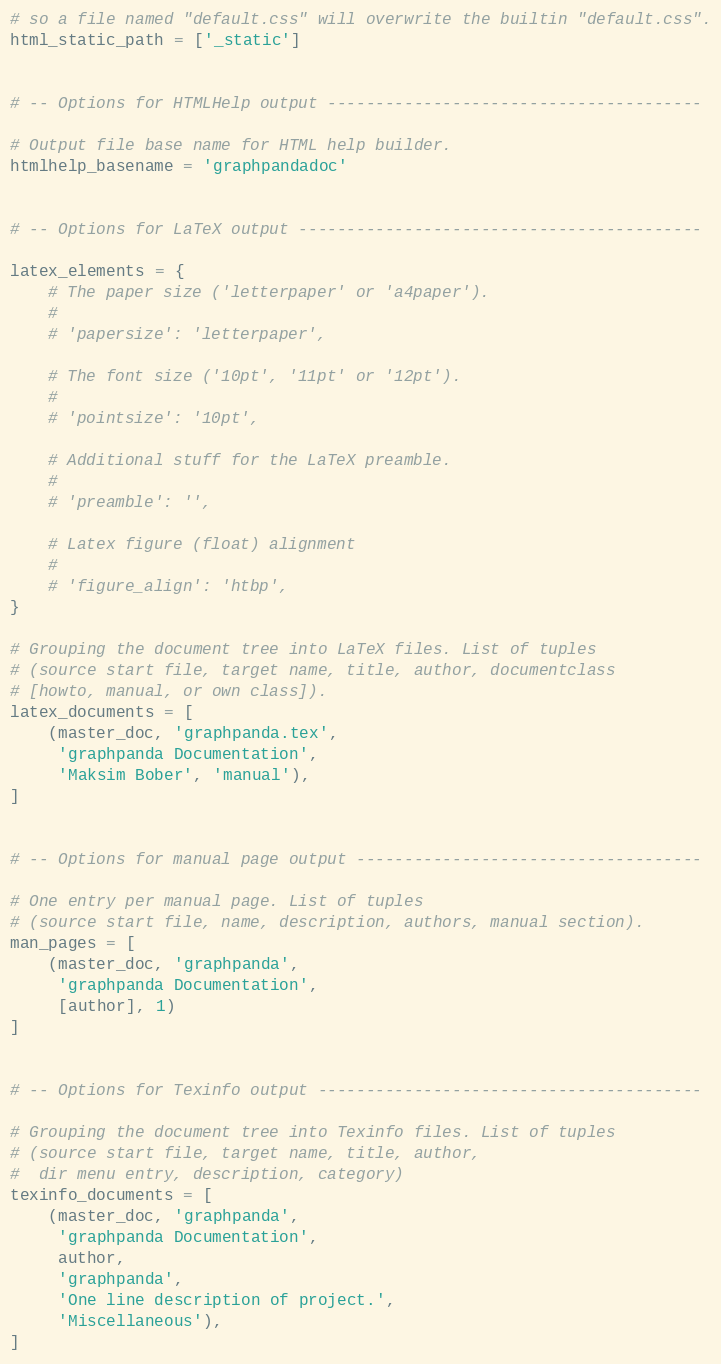<code> <loc_0><loc_0><loc_500><loc_500><_Python_># so a file named "default.css" will overwrite the builtin "default.css".
html_static_path = ['_static']


# -- Options for HTMLHelp output ---------------------------------------

# Output file base name for HTML help builder.
htmlhelp_basename = 'graphpandadoc'


# -- Options for LaTeX output ------------------------------------------

latex_elements = {
    # The paper size ('letterpaper' or 'a4paper').
    #
    # 'papersize': 'letterpaper',

    # The font size ('10pt', '11pt' or '12pt').
    #
    # 'pointsize': '10pt',

    # Additional stuff for the LaTeX preamble.
    #
    # 'preamble': '',

    # Latex figure (float) alignment
    #
    # 'figure_align': 'htbp',
}

# Grouping the document tree into LaTeX files. List of tuples
# (source start file, target name, title, author, documentclass
# [howto, manual, or own class]).
latex_documents = [
    (master_doc, 'graphpanda.tex',
     'graphpanda Documentation',
     'Maksim Bober', 'manual'),
]


# -- Options for manual page output ------------------------------------

# One entry per manual page. List of tuples
# (source start file, name, description, authors, manual section).
man_pages = [
    (master_doc, 'graphpanda',
     'graphpanda Documentation',
     [author], 1)
]


# -- Options for Texinfo output ----------------------------------------

# Grouping the document tree into Texinfo files. List of tuples
# (source start file, target name, title, author,
#  dir menu entry, description, category)
texinfo_documents = [
    (master_doc, 'graphpanda',
     'graphpanda Documentation',
     author,
     'graphpanda',
     'One line description of project.',
     'Miscellaneous'),
]



</code> 